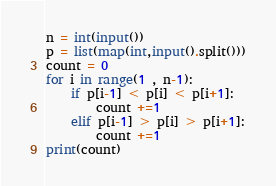Convert code to text. <code><loc_0><loc_0><loc_500><loc_500><_Python_>n = int(input())
p = list(map(int,input().split()))
count = 0
for i in range(1 , n-1):
    if p[i-1] < p[i] < p[i+1]:
        count +=1 
    elif p[i-1] > p[i] > p[i+1]:
        count +=1 
print(count) 
</code> 